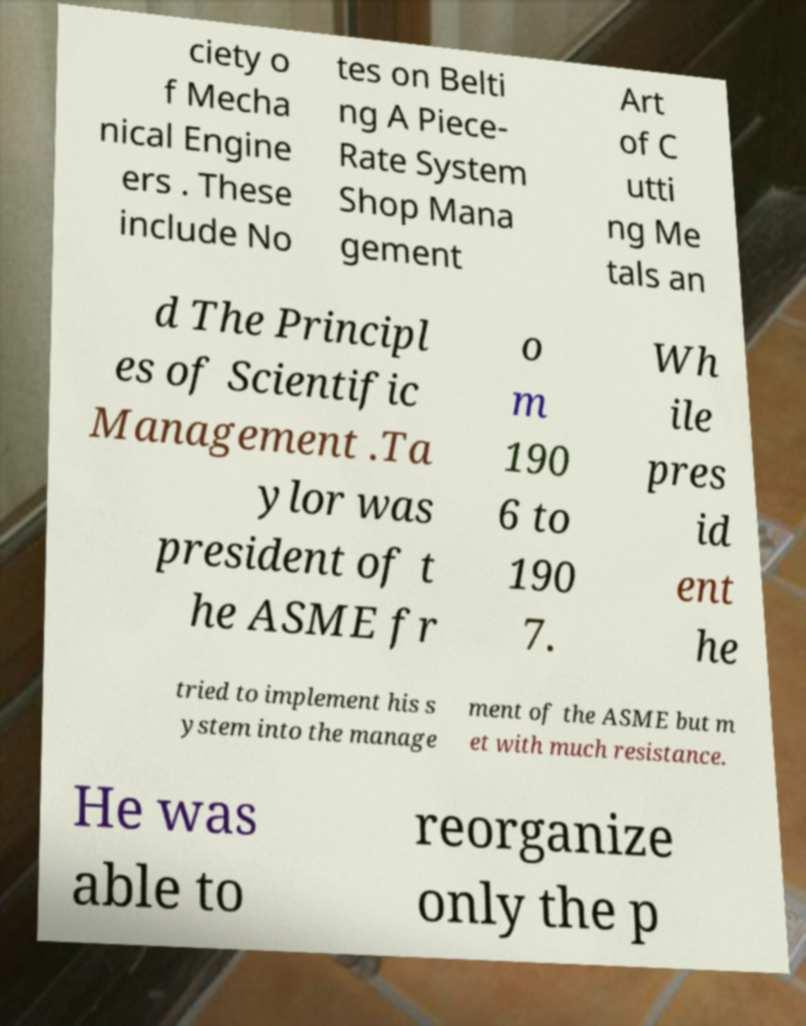Please identify and transcribe the text found in this image. ciety o f Mecha nical Engine ers . These include No tes on Belti ng A Piece- Rate System Shop Mana gement Art of C utti ng Me tals an d The Principl es of Scientific Management .Ta ylor was president of t he ASME fr o m 190 6 to 190 7. Wh ile pres id ent he tried to implement his s ystem into the manage ment of the ASME but m et with much resistance. He was able to reorganize only the p 